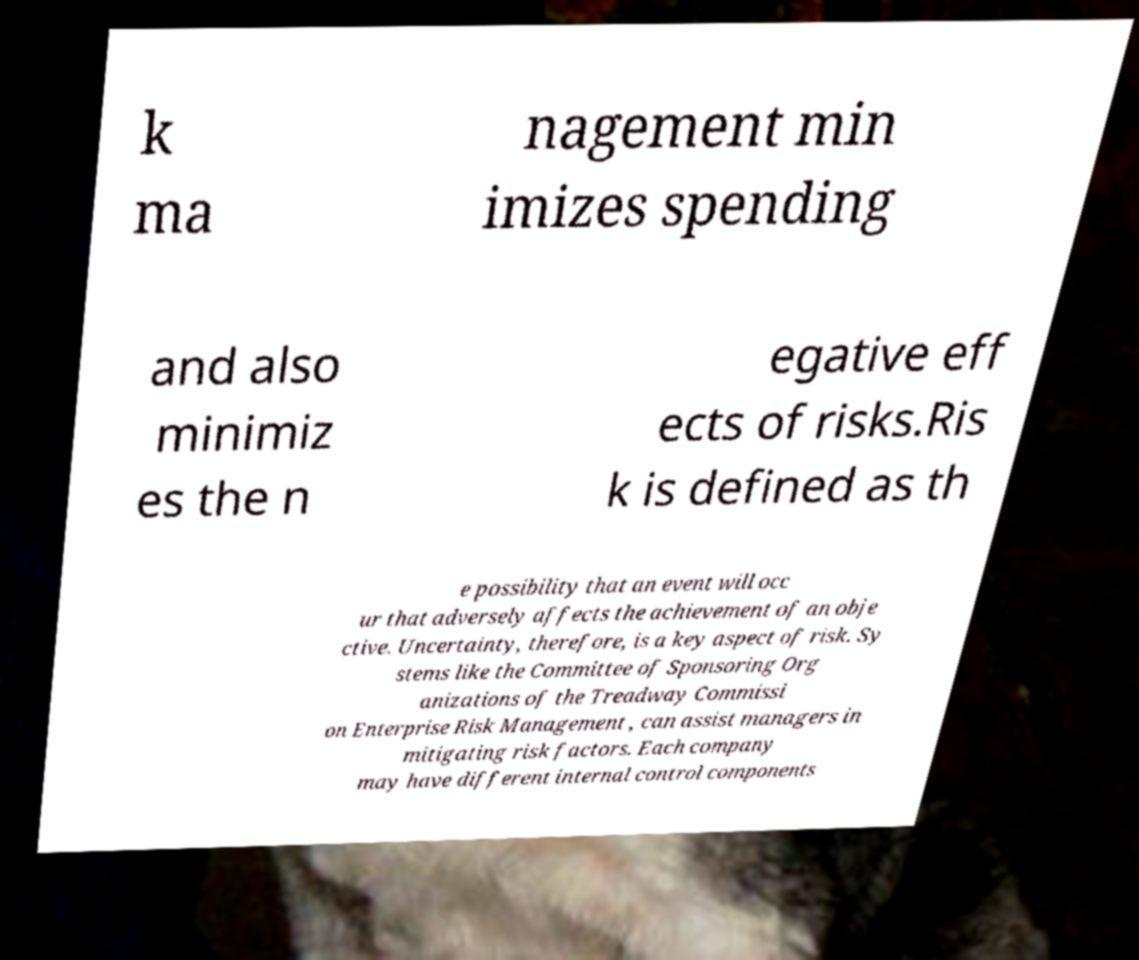For documentation purposes, I need the text within this image transcribed. Could you provide that? k ma nagement min imizes spending and also minimiz es the n egative eff ects of risks.Ris k is defined as th e possibility that an event will occ ur that adversely affects the achievement of an obje ctive. Uncertainty, therefore, is a key aspect of risk. Sy stems like the Committee of Sponsoring Org anizations of the Treadway Commissi on Enterprise Risk Management , can assist managers in mitigating risk factors. Each company may have different internal control components 